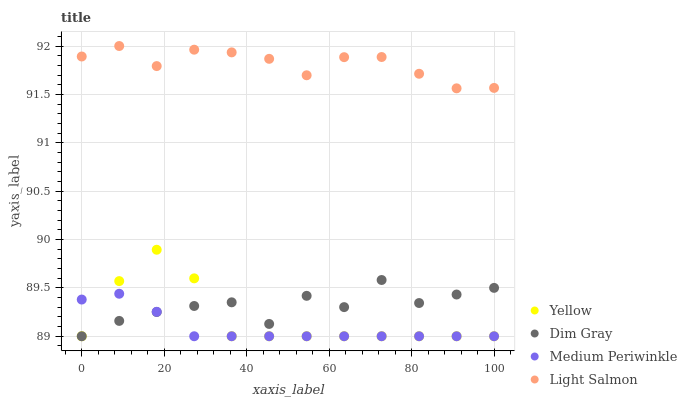Does Medium Periwinkle have the minimum area under the curve?
Answer yes or no. Yes. Does Light Salmon have the maximum area under the curve?
Answer yes or no. Yes. Does Dim Gray have the minimum area under the curve?
Answer yes or no. No. Does Dim Gray have the maximum area under the curve?
Answer yes or no. No. Is Medium Periwinkle the smoothest?
Answer yes or no. Yes. Is Dim Gray the roughest?
Answer yes or no. Yes. Is Dim Gray the smoothest?
Answer yes or no. No. Is Medium Periwinkle the roughest?
Answer yes or no. No. Does Dim Gray have the lowest value?
Answer yes or no. Yes. Does Light Salmon have the highest value?
Answer yes or no. Yes. Does Dim Gray have the highest value?
Answer yes or no. No. Is Yellow less than Light Salmon?
Answer yes or no. Yes. Is Light Salmon greater than Yellow?
Answer yes or no. Yes. Does Dim Gray intersect Yellow?
Answer yes or no. Yes. Is Dim Gray less than Yellow?
Answer yes or no. No. Is Dim Gray greater than Yellow?
Answer yes or no. No. Does Yellow intersect Light Salmon?
Answer yes or no. No. 